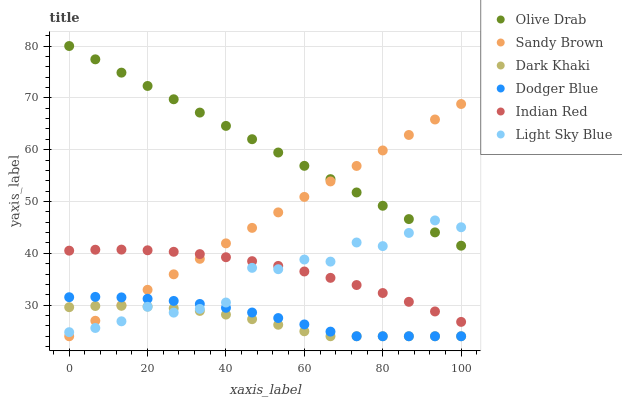Does Dark Khaki have the minimum area under the curve?
Answer yes or no. Yes. Does Olive Drab have the maximum area under the curve?
Answer yes or no. Yes. Does Light Sky Blue have the minimum area under the curve?
Answer yes or no. No. Does Light Sky Blue have the maximum area under the curve?
Answer yes or no. No. Is Olive Drab the smoothest?
Answer yes or no. Yes. Is Light Sky Blue the roughest?
Answer yes or no. Yes. Is Dodger Blue the smoothest?
Answer yes or no. No. Is Dodger Blue the roughest?
Answer yes or no. No. Does Dark Khaki have the lowest value?
Answer yes or no. Yes. Does Light Sky Blue have the lowest value?
Answer yes or no. No. Does Olive Drab have the highest value?
Answer yes or no. Yes. Does Light Sky Blue have the highest value?
Answer yes or no. No. Is Indian Red less than Olive Drab?
Answer yes or no. Yes. Is Olive Drab greater than Dark Khaki?
Answer yes or no. Yes. Does Sandy Brown intersect Olive Drab?
Answer yes or no. Yes. Is Sandy Brown less than Olive Drab?
Answer yes or no. No. Is Sandy Brown greater than Olive Drab?
Answer yes or no. No. Does Indian Red intersect Olive Drab?
Answer yes or no. No. 